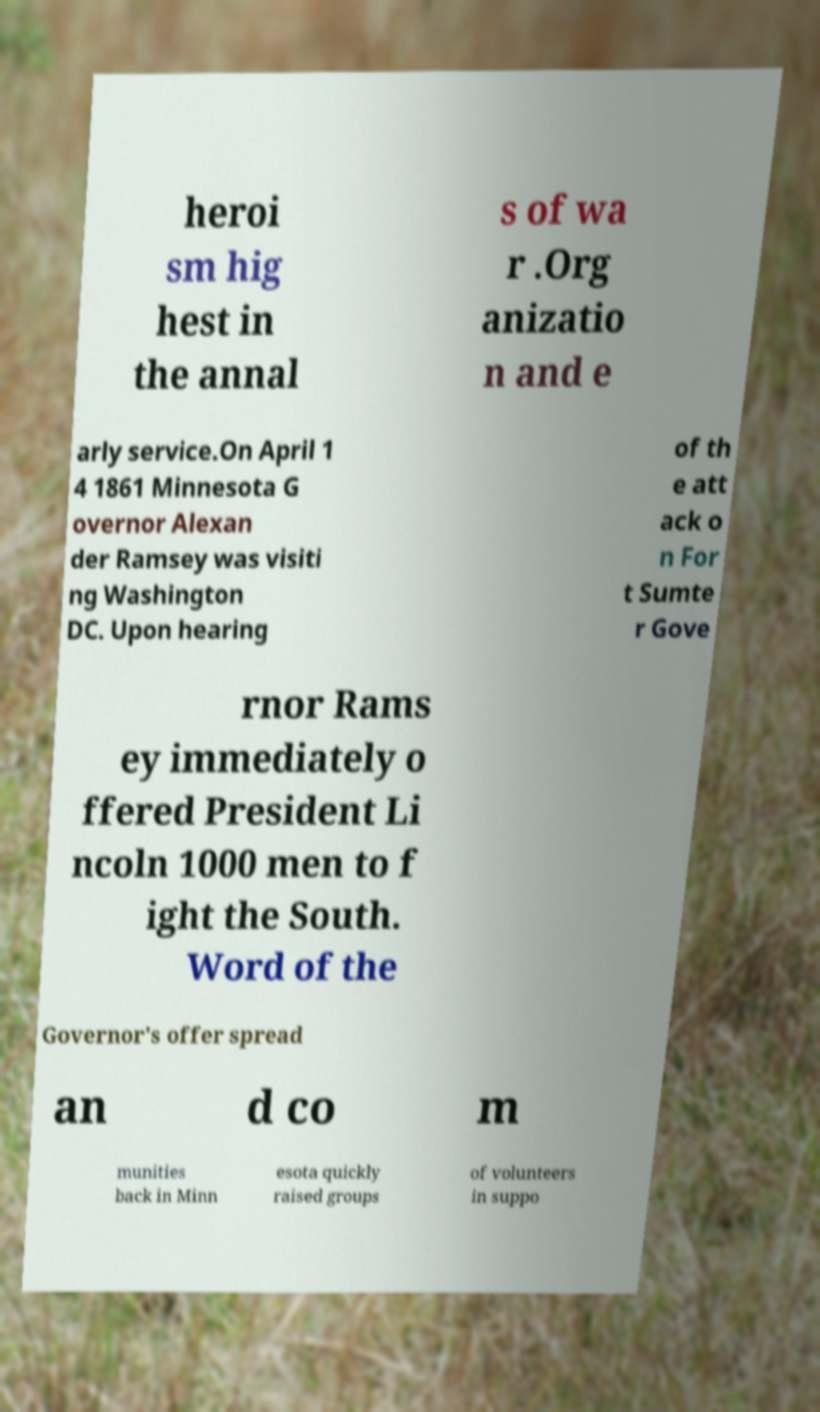Please read and relay the text visible in this image. What does it say? heroi sm hig hest in the annal s of wa r .Org anizatio n and e arly service.On April 1 4 1861 Minnesota G overnor Alexan der Ramsey was visiti ng Washington DC. Upon hearing of th e att ack o n For t Sumte r Gove rnor Rams ey immediately o ffered President Li ncoln 1000 men to f ight the South. Word of the Governor's offer spread an d co m munities back in Minn esota quickly raised groups of volunteers in suppo 